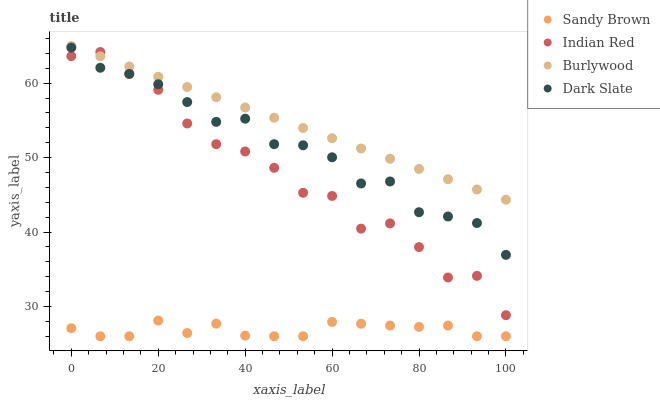Does Sandy Brown have the minimum area under the curve?
Answer yes or no. Yes. Does Burlywood have the maximum area under the curve?
Answer yes or no. Yes. Does Dark Slate have the minimum area under the curve?
Answer yes or no. No. Does Dark Slate have the maximum area under the curve?
Answer yes or no. No. Is Burlywood the smoothest?
Answer yes or no. Yes. Is Indian Red the roughest?
Answer yes or no. Yes. Is Dark Slate the smoothest?
Answer yes or no. No. Is Dark Slate the roughest?
Answer yes or no. No. Does Sandy Brown have the lowest value?
Answer yes or no. Yes. Does Dark Slate have the lowest value?
Answer yes or no. No. Does Burlywood have the highest value?
Answer yes or no. Yes. Does Dark Slate have the highest value?
Answer yes or no. No. Is Dark Slate less than Burlywood?
Answer yes or no. Yes. Is Dark Slate greater than Sandy Brown?
Answer yes or no. Yes. Does Indian Red intersect Dark Slate?
Answer yes or no. Yes. Is Indian Red less than Dark Slate?
Answer yes or no. No. Is Indian Red greater than Dark Slate?
Answer yes or no. No. Does Dark Slate intersect Burlywood?
Answer yes or no. No. 